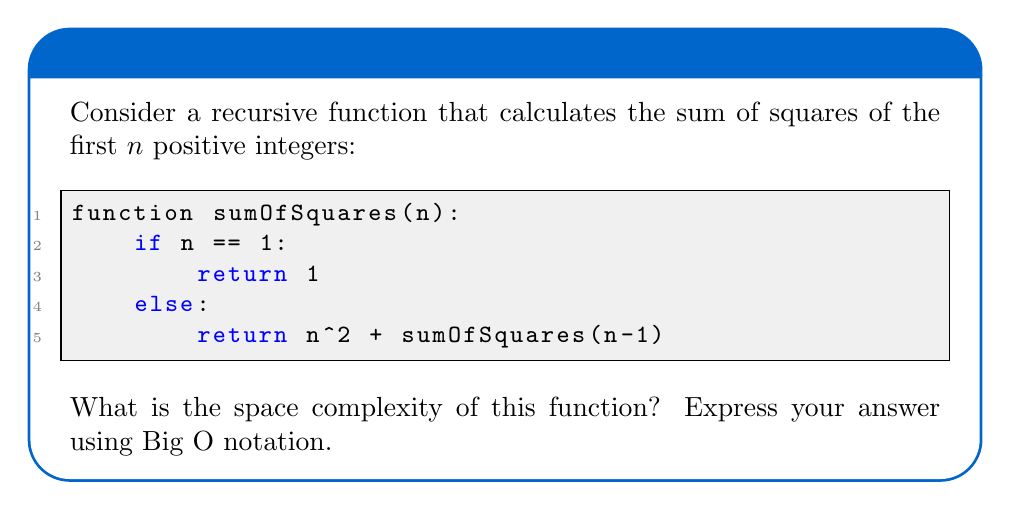Help me with this question. To determine the space complexity of a recursive function, we need to consider the maximum depth of the recursion stack and any additional space used by local variables.

1. Recursion depth:
   - The function calls itself with n-1 until it reaches the base case (n = 1).
   - This means the recursion depth is n.

2. Local variables:
   - Each recursive call uses a constant amount of space for the parameter n and the return value.
   - No additional data structures are created.

3. Stack frame analysis:
   - Each recursive call creates a new stack frame.
   - The stack grows linearly with the input size n.

4. Maximum space usage:
   - At the deepest point of recursion, there will be n stack frames.
   - Each stack frame uses constant space.

5. Big O notation:
   - The space complexity is proportional to the depth of recursion.
   - Therefore, the space complexity is $O(n)$.

Note: This linear space complexity is due to the recursive nature of the function. An iterative version of this algorithm could achieve $O(1)$ space complexity.
Answer: The space complexity of the given recursive function is $O(n)$. 